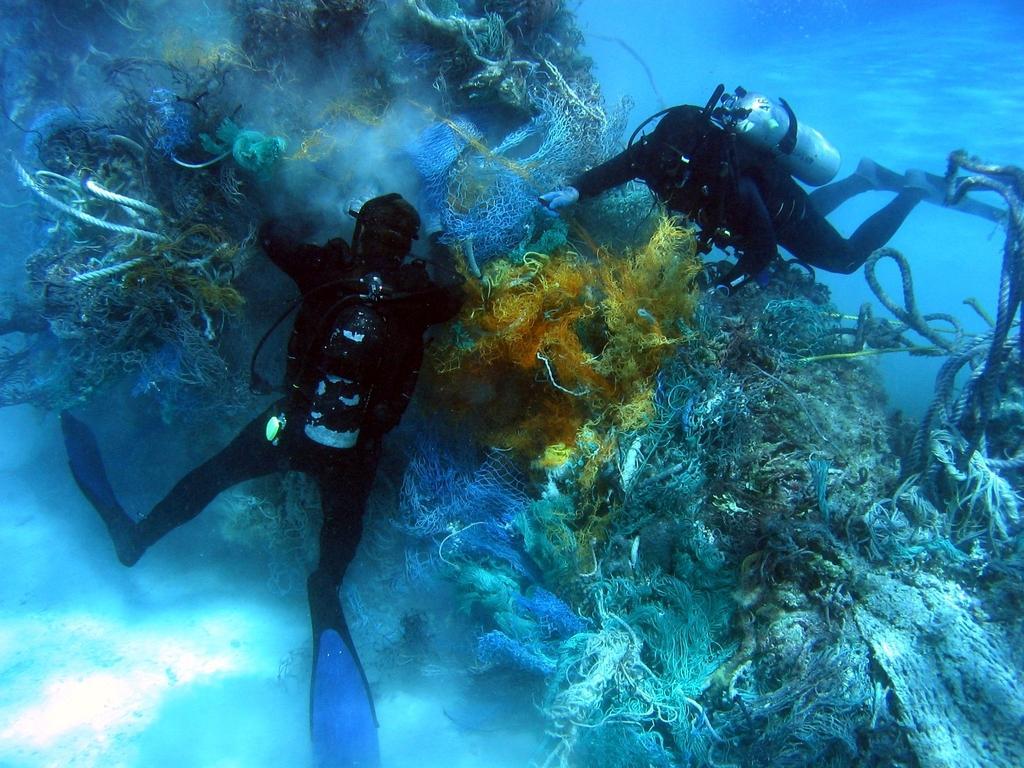Could you give a brief overview of what you see in this image? Here we can see two persons inside the water and there are cylinders and ropes. 